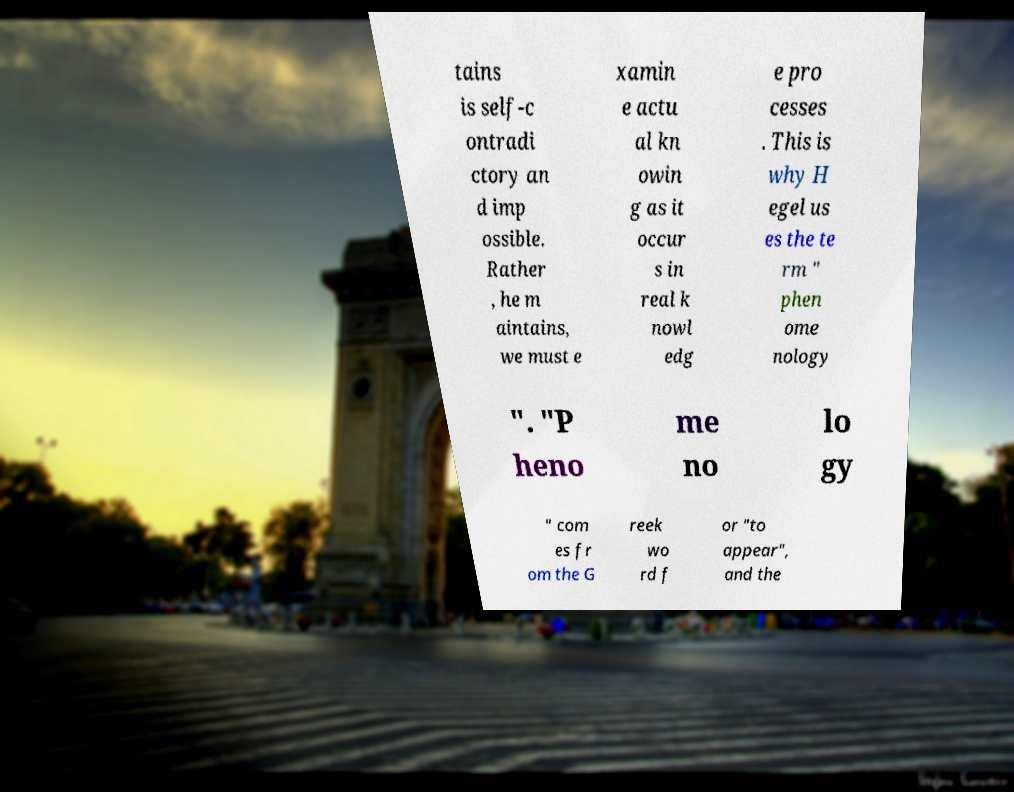Could you extract and type out the text from this image? tains is self-c ontradi ctory an d imp ossible. Rather , he m aintains, we must e xamin e actu al kn owin g as it occur s in real k nowl edg e pro cesses . This is why H egel us es the te rm " phen ome nology ". "P heno me no lo gy " com es fr om the G reek wo rd f or "to appear", and the 